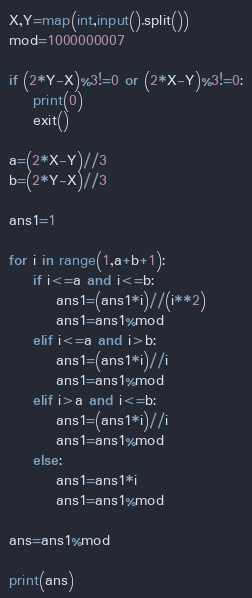<code> <loc_0><loc_0><loc_500><loc_500><_Python_>
X,Y=map(int,input().split())
mod=1000000007

if (2*Y-X)%3!=0 or (2*X-Y)%3!=0:
    print(0)
    exit()

a=(2*X-Y)//3
b=(2*Y-X)//3

ans1=1

for i in range(1,a+b+1):
    if i<=a and i<=b:
        ans1=(ans1*i)//(i**2)
        ans1=ans1%mod
    elif i<=a and i>b:
        ans1=(ans1*i)//i
        ans1=ans1%mod
    elif i>a and i<=b:
        ans1=(ans1*i)//i
        ans1=ans1%mod
    else:
        ans1=ans1*i
        ans1=ans1%mod

ans=ans1%mod

print(ans)

</code> 